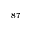<formula> <loc_0><loc_0><loc_500><loc_500>^ { 8 7 }</formula> 